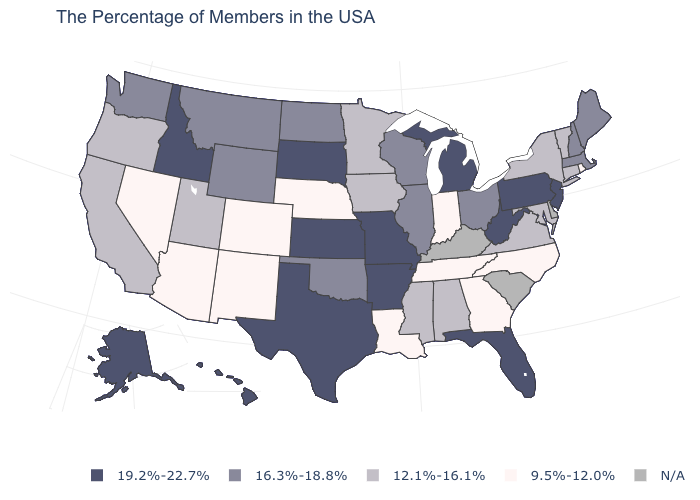What is the value of Maryland?
Concise answer only. 12.1%-16.1%. Which states have the lowest value in the USA?
Write a very short answer. Rhode Island, North Carolina, Georgia, Indiana, Tennessee, Louisiana, Nebraska, Colorado, New Mexico, Arizona, Nevada. Name the states that have a value in the range N/A?
Be succinct. Delaware, South Carolina, Kentucky. What is the value of Nebraska?
Concise answer only. 9.5%-12.0%. What is the value of West Virginia?
Concise answer only. 19.2%-22.7%. Which states have the lowest value in the West?
Short answer required. Colorado, New Mexico, Arizona, Nevada. What is the value of Mississippi?
Short answer required. 12.1%-16.1%. Which states have the lowest value in the West?
Keep it brief. Colorado, New Mexico, Arizona, Nevada. What is the value of Massachusetts?
Give a very brief answer. 16.3%-18.8%. What is the value of West Virginia?
Short answer required. 19.2%-22.7%. What is the value of Texas?
Answer briefly. 19.2%-22.7%. Does the first symbol in the legend represent the smallest category?
Give a very brief answer. No. 